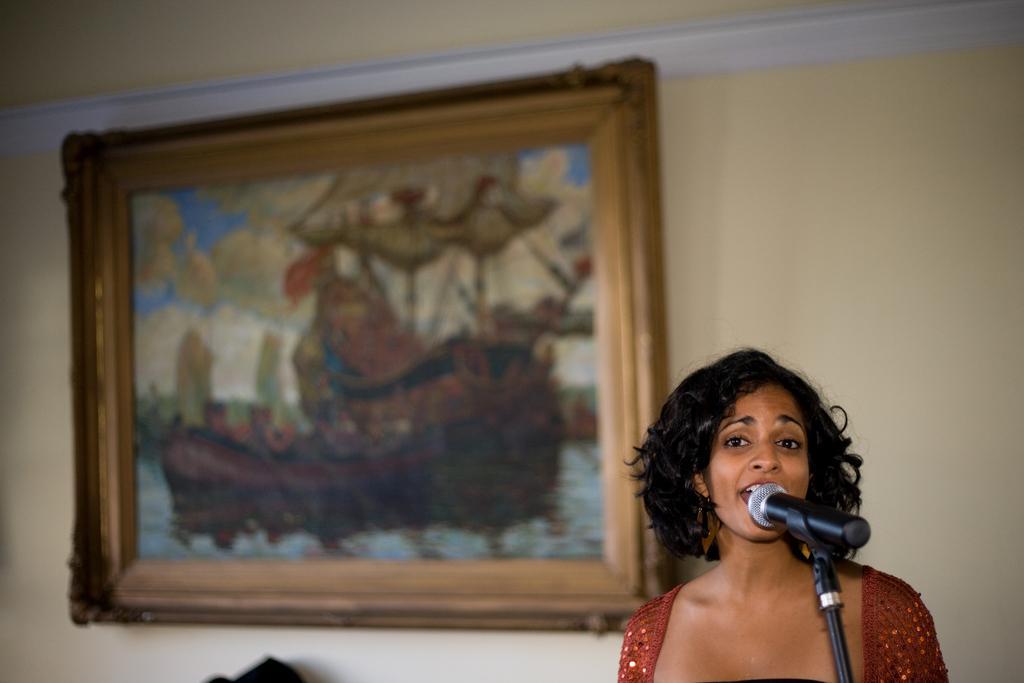In one or two sentences, can you explain what this image depicts? In the picture there is a woman, she is singing a song there is a mic in front of her and in the background there is a wall and a photo frame attached to the wall. 